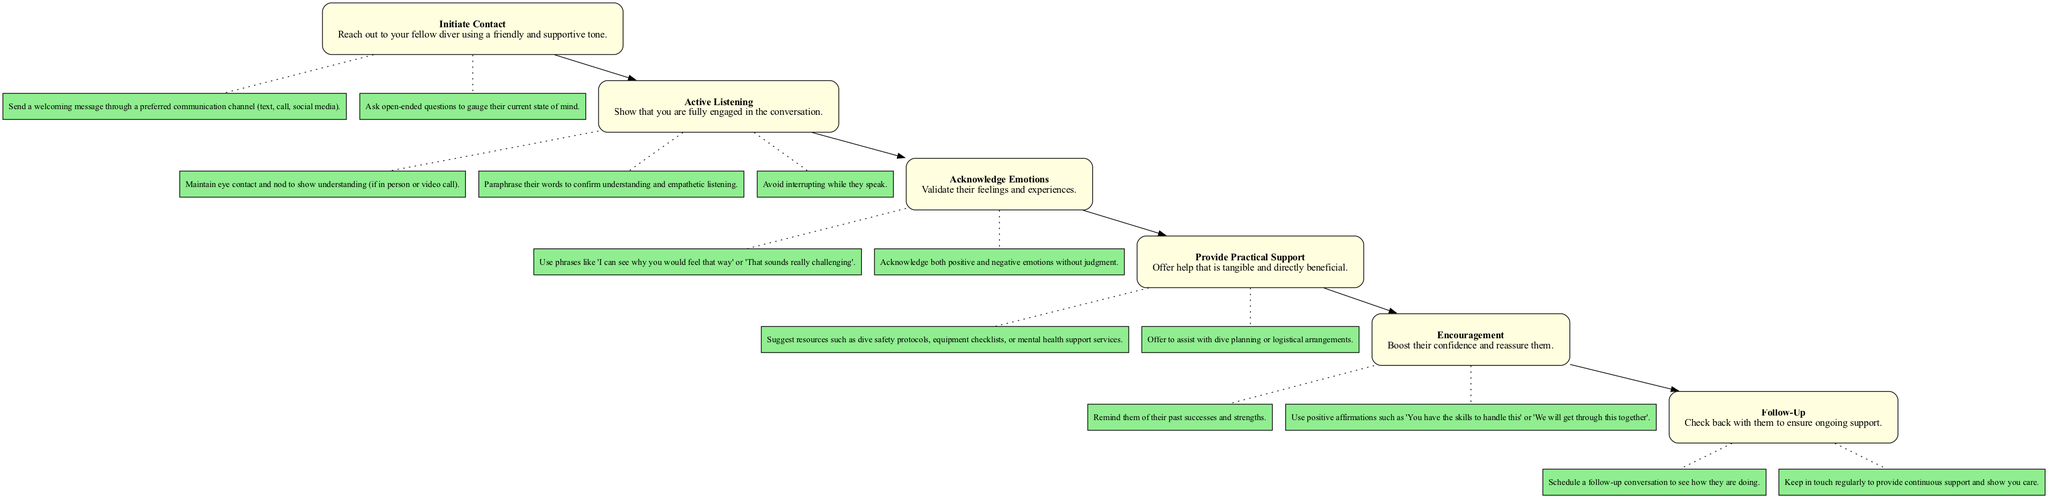What is the first step in the guide? The first step is labeled as "Initiate Contact" and is positioned at the top of the flow chart. It is the initial node from which the sequence proceeds.
Answer: Initiate Contact How many total steps are there in the diagram? By counting each main step illustrated in the flow chart, there are six distinct steps represented in the diagram.
Answer: 6 Which step follows "Acknowledge Emotions"? The diagram indicates that the step following "Acknowledge Emotions" is "Provide Practical Support." This can be determined by looking at the directional arrows connecting the steps.
Answer: Provide Practical Support What type of actions do you take during the "Active Listening" step? The actions associated with "Active Listening," represented in the diagram with dotted lines leading from the respective step, focus on engagement and understanding during the conversation.
Answer: Maintain eye contact, paraphrase, avoid interrupting How does "Encouragement" relate to the "Follow-Up" step? "Encouragement" is placed before "Follow-Up" in the sequence of steps. The flow chart depicts a direct connection through an edge indicating that encouragement should occur prior to following up with the individual.
Answer: "Encouragement" leads to "Follow-Up" What is the last action mentioned in the "Follow-Up" step? The last action listed under "Follow-Up" in the diagram is about keeping in touch regularly, which emphasizes the necessity for continuous interaction to provide support.
Answer: Keep in touch regularly What key phrase is recommended in the "Acknowledge Emotions" step? The recommended key phrases in "Acknowledge Emotions," as shown in the diagram, include affirmations like ‘I can see why you would feel that way’ to validate the person's feelings and experiences.
Answer: I can see why you would feel that way Which step directly precedes "Encouragement"? The diagram clearly indicates that "Provide Practical Support" precedes "Encouragement," with an arrow connecting the two steps in the sequence.
Answer: Provide Practical Support 